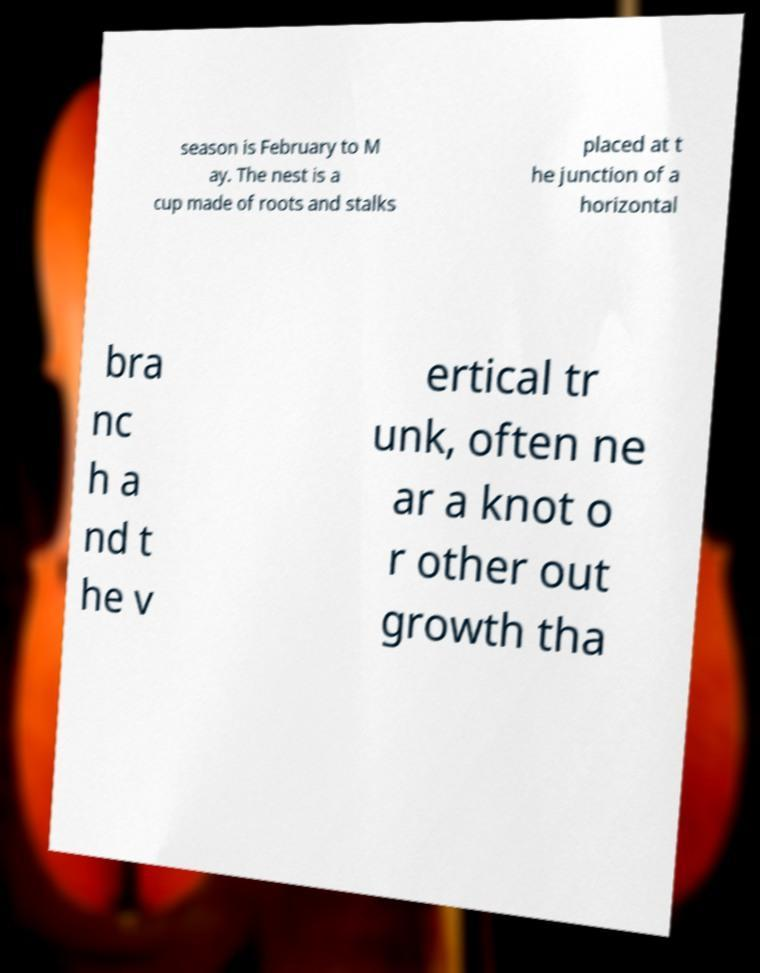What messages or text are displayed in this image? I need them in a readable, typed format. season is February to M ay. The nest is a cup made of roots and stalks placed at t he junction of a horizontal bra nc h a nd t he v ertical tr unk, often ne ar a knot o r other out growth tha 